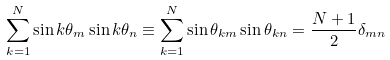Convert formula to latex. <formula><loc_0><loc_0><loc_500><loc_500>\sum _ { k = 1 } ^ { N } \sin k \theta _ { m } \sin k \theta _ { n } \equiv \sum _ { k = 1 } ^ { N } \sin \theta _ { k m } \sin \theta _ { k n } = \frac { N + 1 } { 2 } \delta _ { m n }</formula> 